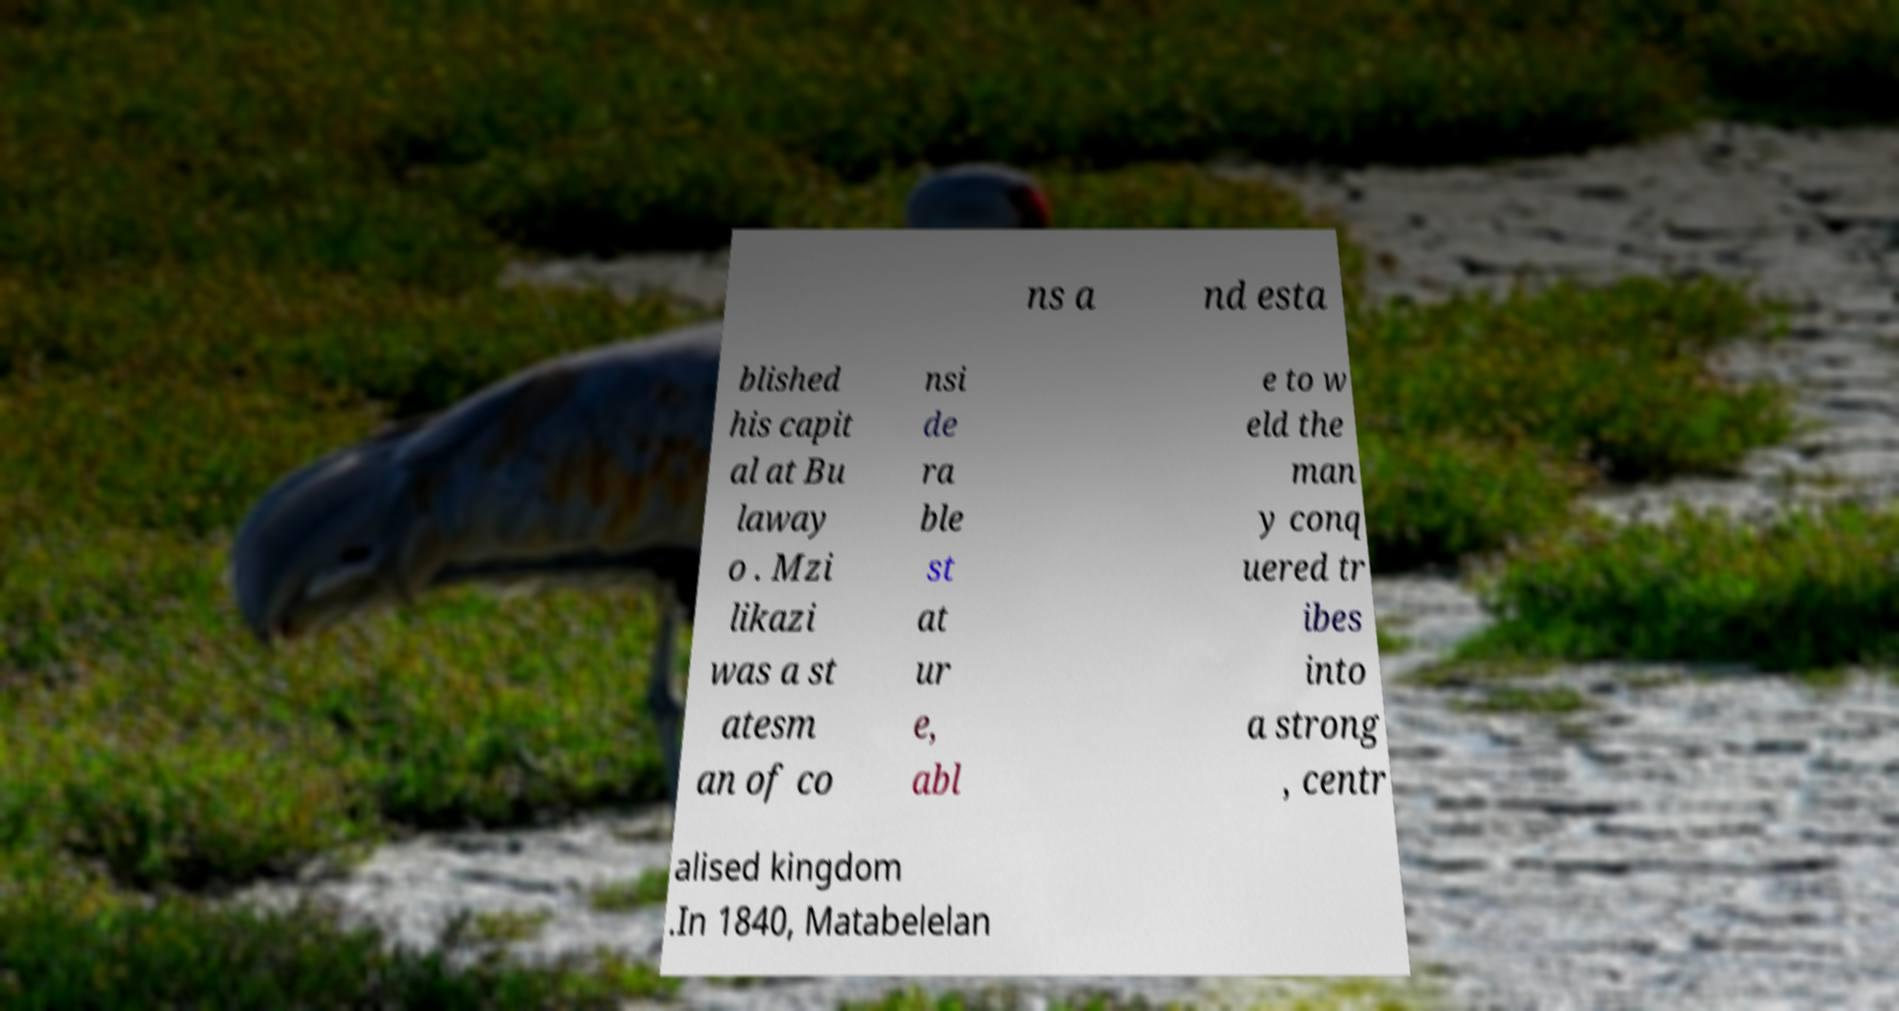Please identify and transcribe the text found in this image. ns a nd esta blished his capit al at Bu laway o . Mzi likazi was a st atesm an of co nsi de ra ble st at ur e, abl e to w eld the man y conq uered tr ibes into a strong , centr alised kingdom .In 1840, Matabelelan 